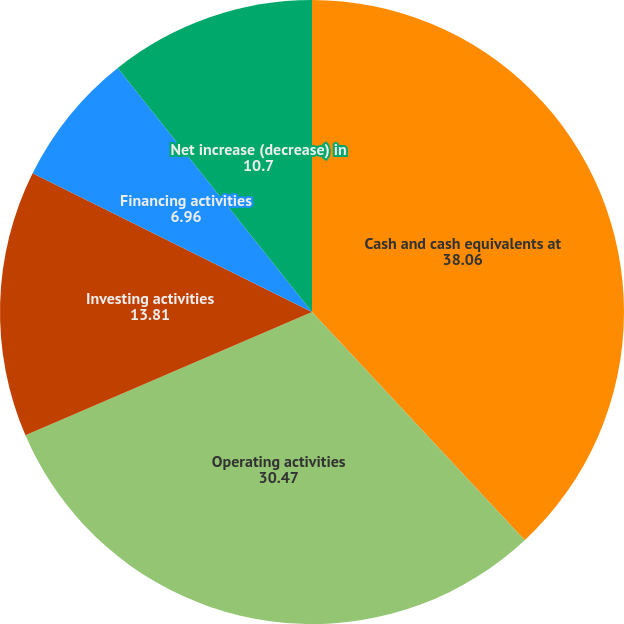Convert chart to OTSL. <chart><loc_0><loc_0><loc_500><loc_500><pie_chart><fcel>Cash and cash equivalents at<fcel>Operating activities<fcel>Investing activities<fcel>Financing activities<fcel>Net increase (decrease) in<nl><fcel>38.06%<fcel>30.47%<fcel>13.81%<fcel>6.96%<fcel>10.7%<nl></chart> 